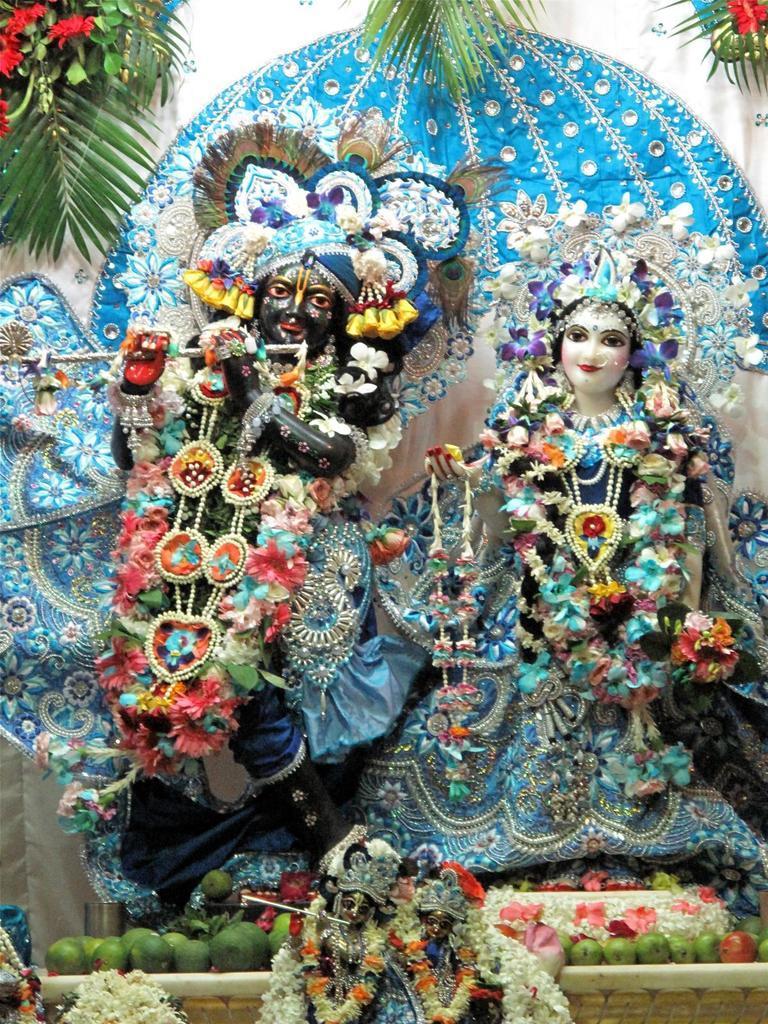How would you summarize this image in a sentence or two? In this image there are idols of god, garlands, leaves, flowers, fruits and objects. 